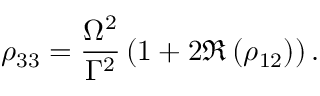<formula> <loc_0><loc_0><loc_500><loc_500>\rho _ { 3 3 } = \frac { \Omega ^ { 2 } } { \Gamma ^ { 2 } } \left ( 1 + 2 \Re \left ( \rho _ { 1 2 } \right ) \right ) .</formula> 